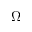Convert formula to latex. <formula><loc_0><loc_0><loc_500><loc_500>\Omega</formula> 